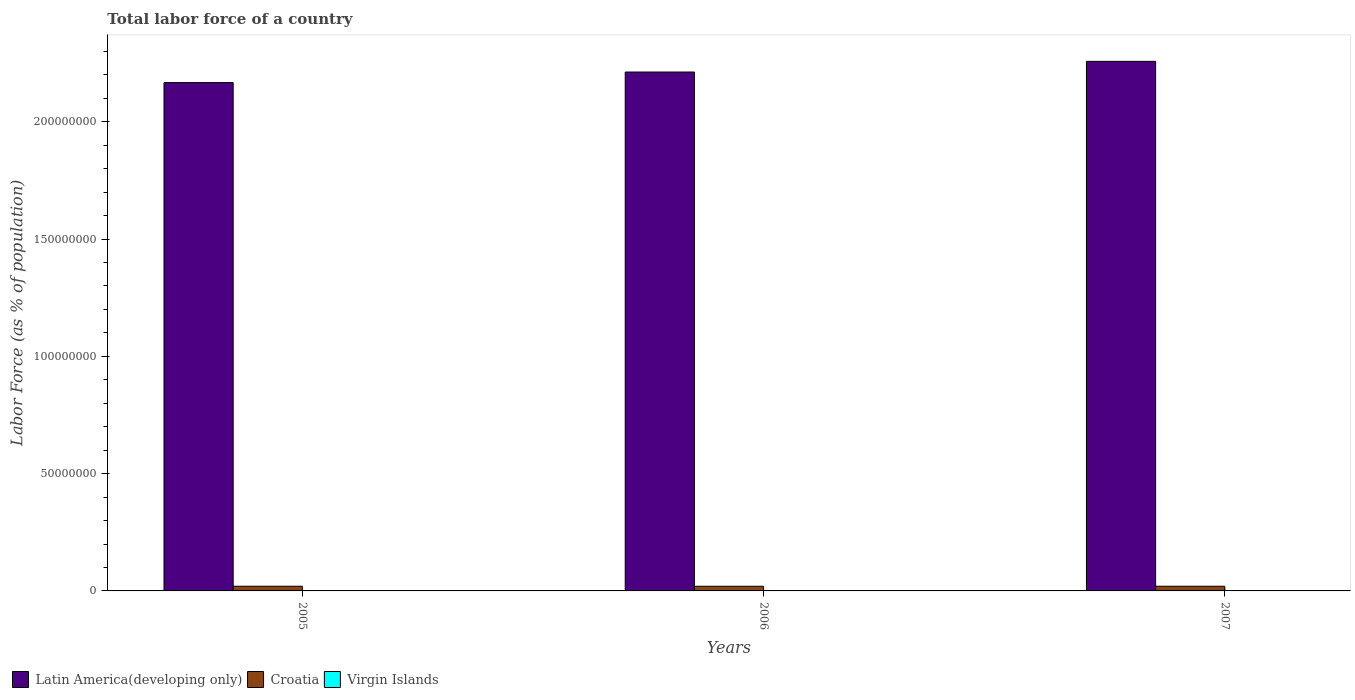Are the number of bars per tick equal to the number of legend labels?
Make the answer very short. Yes. Are the number of bars on each tick of the X-axis equal?
Provide a short and direct response. Yes. How many bars are there on the 1st tick from the right?
Offer a terse response. 3. What is the percentage of labor force in Croatia in 2006?
Provide a succinct answer. 1.99e+06. Across all years, what is the maximum percentage of labor force in Virgin Islands?
Your answer should be very brief. 5.45e+04. Across all years, what is the minimum percentage of labor force in Latin America(developing only)?
Give a very brief answer. 2.17e+08. In which year was the percentage of labor force in Croatia maximum?
Keep it short and to the point. 2005. What is the total percentage of labor force in Virgin Islands in the graph?
Your response must be concise. 1.63e+05. What is the difference between the percentage of labor force in Virgin Islands in 2005 and that in 2007?
Provide a succinct answer. -164. What is the difference between the percentage of labor force in Croatia in 2007 and the percentage of labor force in Latin America(developing only) in 2006?
Offer a terse response. -2.19e+08. What is the average percentage of labor force in Virgin Islands per year?
Ensure brevity in your answer.  5.44e+04. In the year 2006, what is the difference between the percentage of labor force in Latin America(developing only) and percentage of labor force in Virgin Islands?
Ensure brevity in your answer.  2.21e+08. What is the ratio of the percentage of labor force in Latin America(developing only) in 2006 to that in 2007?
Your response must be concise. 0.98. What is the difference between the highest and the second highest percentage of labor force in Croatia?
Your answer should be very brief. 6002. What is the difference between the highest and the lowest percentage of labor force in Croatia?
Your answer should be very brief. 1.29e+04. What does the 1st bar from the left in 2006 represents?
Your response must be concise. Latin America(developing only). What does the 2nd bar from the right in 2006 represents?
Ensure brevity in your answer.  Croatia. Are all the bars in the graph horizontal?
Ensure brevity in your answer.  No. How many years are there in the graph?
Provide a succinct answer. 3. Are the values on the major ticks of Y-axis written in scientific E-notation?
Your answer should be very brief. No. Does the graph contain any zero values?
Provide a succinct answer. No. Where does the legend appear in the graph?
Give a very brief answer. Bottom left. How are the legend labels stacked?
Your answer should be compact. Horizontal. What is the title of the graph?
Your response must be concise. Total labor force of a country. Does "Sub-Saharan Africa (all income levels)" appear as one of the legend labels in the graph?
Provide a succinct answer. No. What is the label or title of the X-axis?
Give a very brief answer. Years. What is the label or title of the Y-axis?
Your response must be concise. Labor Force (as % of population). What is the Labor Force (as % of population) in Latin America(developing only) in 2005?
Your response must be concise. 2.17e+08. What is the Labor Force (as % of population) in Croatia in 2005?
Give a very brief answer. 2.00e+06. What is the Labor Force (as % of population) in Virgin Islands in 2005?
Your answer should be compact. 5.43e+04. What is the Labor Force (as % of population) in Latin America(developing only) in 2006?
Give a very brief answer. 2.21e+08. What is the Labor Force (as % of population) in Croatia in 2006?
Provide a succinct answer. 1.99e+06. What is the Labor Force (as % of population) in Virgin Islands in 2006?
Provide a succinct answer. 5.44e+04. What is the Labor Force (as % of population) in Latin America(developing only) in 2007?
Provide a short and direct response. 2.26e+08. What is the Labor Force (as % of population) in Croatia in 2007?
Your answer should be very brief. 1.99e+06. What is the Labor Force (as % of population) in Virgin Islands in 2007?
Your answer should be compact. 5.45e+04. Across all years, what is the maximum Labor Force (as % of population) of Latin America(developing only)?
Keep it short and to the point. 2.26e+08. Across all years, what is the maximum Labor Force (as % of population) in Croatia?
Keep it short and to the point. 2.00e+06. Across all years, what is the maximum Labor Force (as % of population) of Virgin Islands?
Make the answer very short. 5.45e+04. Across all years, what is the minimum Labor Force (as % of population) in Latin America(developing only)?
Offer a terse response. 2.17e+08. Across all years, what is the minimum Labor Force (as % of population) in Croatia?
Your answer should be compact. 1.99e+06. Across all years, what is the minimum Labor Force (as % of population) of Virgin Islands?
Your answer should be compact. 5.43e+04. What is the total Labor Force (as % of population) in Latin America(developing only) in the graph?
Provide a short and direct response. 6.64e+08. What is the total Labor Force (as % of population) of Croatia in the graph?
Ensure brevity in your answer.  5.98e+06. What is the total Labor Force (as % of population) of Virgin Islands in the graph?
Your answer should be very brief. 1.63e+05. What is the difference between the Labor Force (as % of population) of Latin America(developing only) in 2005 and that in 2006?
Provide a short and direct response. -4.50e+06. What is the difference between the Labor Force (as % of population) in Croatia in 2005 and that in 2006?
Your response must be concise. 1.29e+04. What is the difference between the Labor Force (as % of population) of Virgin Islands in 2005 and that in 2006?
Your answer should be very brief. -107. What is the difference between the Labor Force (as % of population) in Latin America(developing only) in 2005 and that in 2007?
Ensure brevity in your answer.  -9.05e+06. What is the difference between the Labor Force (as % of population) in Croatia in 2005 and that in 2007?
Ensure brevity in your answer.  6002. What is the difference between the Labor Force (as % of population) of Virgin Islands in 2005 and that in 2007?
Keep it short and to the point. -164. What is the difference between the Labor Force (as % of population) in Latin America(developing only) in 2006 and that in 2007?
Offer a very short reply. -4.55e+06. What is the difference between the Labor Force (as % of population) in Croatia in 2006 and that in 2007?
Provide a succinct answer. -6861. What is the difference between the Labor Force (as % of population) in Virgin Islands in 2006 and that in 2007?
Provide a succinct answer. -57. What is the difference between the Labor Force (as % of population) in Latin America(developing only) in 2005 and the Labor Force (as % of population) in Croatia in 2006?
Offer a terse response. 2.15e+08. What is the difference between the Labor Force (as % of population) in Latin America(developing only) in 2005 and the Labor Force (as % of population) in Virgin Islands in 2006?
Give a very brief answer. 2.17e+08. What is the difference between the Labor Force (as % of population) of Croatia in 2005 and the Labor Force (as % of population) of Virgin Islands in 2006?
Offer a terse response. 1.94e+06. What is the difference between the Labor Force (as % of population) in Latin America(developing only) in 2005 and the Labor Force (as % of population) in Croatia in 2007?
Ensure brevity in your answer.  2.15e+08. What is the difference between the Labor Force (as % of population) in Latin America(developing only) in 2005 and the Labor Force (as % of population) in Virgin Islands in 2007?
Your answer should be very brief. 2.17e+08. What is the difference between the Labor Force (as % of population) in Croatia in 2005 and the Labor Force (as % of population) in Virgin Islands in 2007?
Provide a succinct answer. 1.94e+06. What is the difference between the Labor Force (as % of population) in Latin America(developing only) in 2006 and the Labor Force (as % of population) in Croatia in 2007?
Make the answer very short. 2.19e+08. What is the difference between the Labor Force (as % of population) in Latin America(developing only) in 2006 and the Labor Force (as % of population) in Virgin Islands in 2007?
Provide a short and direct response. 2.21e+08. What is the difference between the Labor Force (as % of population) of Croatia in 2006 and the Labor Force (as % of population) of Virgin Islands in 2007?
Provide a short and direct response. 1.93e+06. What is the average Labor Force (as % of population) of Latin America(developing only) per year?
Keep it short and to the point. 2.21e+08. What is the average Labor Force (as % of population) of Croatia per year?
Make the answer very short. 1.99e+06. What is the average Labor Force (as % of population) in Virgin Islands per year?
Your answer should be compact. 5.44e+04. In the year 2005, what is the difference between the Labor Force (as % of population) in Latin America(developing only) and Labor Force (as % of population) in Croatia?
Ensure brevity in your answer.  2.15e+08. In the year 2005, what is the difference between the Labor Force (as % of population) of Latin America(developing only) and Labor Force (as % of population) of Virgin Islands?
Ensure brevity in your answer.  2.17e+08. In the year 2005, what is the difference between the Labor Force (as % of population) in Croatia and Labor Force (as % of population) in Virgin Islands?
Your answer should be compact. 1.94e+06. In the year 2006, what is the difference between the Labor Force (as % of population) in Latin America(developing only) and Labor Force (as % of population) in Croatia?
Your answer should be very brief. 2.19e+08. In the year 2006, what is the difference between the Labor Force (as % of population) of Latin America(developing only) and Labor Force (as % of population) of Virgin Islands?
Make the answer very short. 2.21e+08. In the year 2006, what is the difference between the Labor Force (as % of population) of Croatia and Labor Force (as % of population) of Virgin Islands?
Keep it short and to the point. 1.93e+06. In the year 2007, what is the difference between the Labor Force (as % of population) of Latin America(developing only) and Labor Force (as % of population) of Croatia?
Offer a terse response. 2.24e+08. In the year 2007, what is the difference between the Labor Force (as % of population) of Latin America(developing only) and Labor Force (as % of population) of Virgin Islands?
Provide a short and direct response. 2.26e+08. In the year 2007, what is the difference between the Labor Force (as % of population) in Croatia and Labor Force (as % of population) in Virgin Islands?
Provide a short and direct response. 1.94e+06. What is the ratio of the Labor Force (as % of population) of Latin America(developing only) in 2005 to that in 2006?
Make the answer very short. 0.98. What is the ratio of the Labor Force (as % of population) of Latin America(developing only) in 2005 to that in 2007?
Keep it short and to the point. 0.96. What is the ratio of the Labor Force (as % of population) in Croatia in 2005 to that in 2007?
Give a very brief answer. 1. What is the ratio of the Labor Force (as % of population) of Virgin Islands in 2005 to that in 2007?
Your answer should be very brief. 1. What is the ratio of the Labor Force (as % of population) of Latin America(developing only) in 2006 to that in 2007?
Your answer should be compact. 0.98. What is the ratio of the Labor Force (as % of population) in Virgin Islands in 2006 to that in 2007?
Keep it short and to the point. 1. What is the difference between the highest and the second highest Labor Force (as % of population) in Latin America(developing only)?
Offer a terse response. 4.55e+06. What is the difference between the highest and the second highest Labor Force (as % of population) in Croatia?
Offer a terse response. 6002. What is the difference between the highest and the second highest Labor Force (as % of population) in Virgin Islands?
Offer a terse response. 57. What is the difference between the highest and the lowest Labor Force (as % of population) in Latin America(developing only)?
Make the answer very short. 9.05e+06. What is the difference between the highest and the lowest Labor Force (as % of population) in Croatia?
Provide a short and direct response. 1.29e+04. What is the difference between the highest and the lowest Labor Force (as % of population) in Virgin Islands?
Your answer should be compact. 164. 